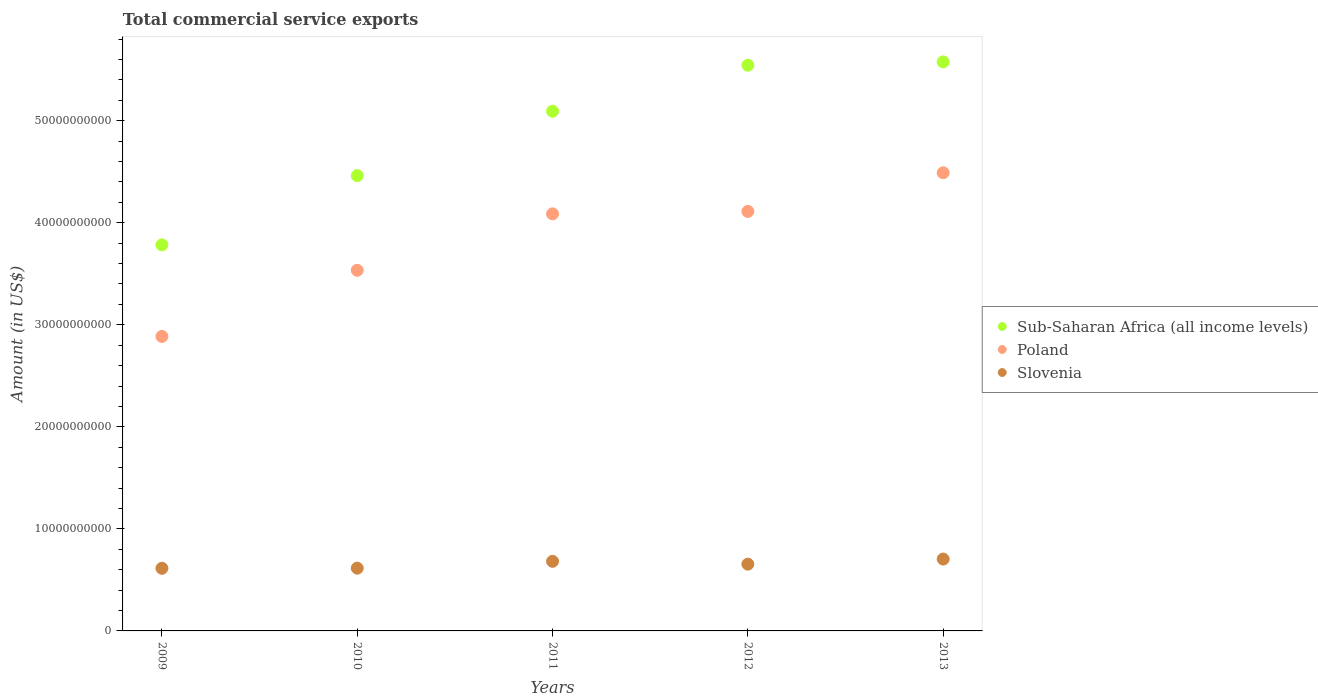Is the number of dotlines equal to the number of legend labels?
Offer a terse response. Yes. What is the total commercial service exports in Poland in 2009?
Provide a short and direct response. 2.89e+1. Across all years, what is the maximum total commercial service exports in Sub-Saharan Africa (all income levels)?
Offer a very short reply. 5.58e+1. Across all years, what is the minimum total commercial service exports in Poland?
Ensure brevity in your answer.  2.89e+1. In which year was the total commercial service exports in Poland maximum?
Provide a short and direct response. 2013. In which year was the total commercial service exports in Sub-Saharan Africa (all income levels) minimum?
Offer a terse response. 2009. What is the total total commercial service exports in Slovenia in the graph?
Keep it short and to the point. 3.27e+1. What is the difference between the total commercial service exports in Slovenia in 2010 and that in 2013?
Offer a terse response. -8.91e+08. What is the difference between the total commercial service exports in Slovenia in 2013 and the total commercial service exports in Poland in 2012?
Ensure brevity in your answer.  -3.41e+1. What is the average total commercial service exports in Sub-Saharan Africa (all income levels) per year?
Offer a very short reply. 4.89e+1. In the year 2011, what is the difference between the total commercial service exports in Poland and total commercial service exports in Slovenia?
Keep it short and to the point. 3.41e+1. What is the ratio of the total commercial service exports in Slovenia in 2009 to that in 2011?
Ensure brevity in your answer.  0.9. Is the total commercial service exports in Poland in 2009 less than that in 2012?
Make the answer very short. Yes. What is the difference between the highest and the second highest total commercial service exports in Sub-Saharan Africa (all income levels)?
Keep it short and to the point. 3.24e+08. What is the difference between the highest and the lowest total commercial service exports in Sub-Saharan Africa (all income levels)?
Your response must be concise. 1.79e+1. Is the sum of the total commercial service exports in Slovenia in 2009 and 2011 greater than the maximum total commercial service exports in Poland across all years?
Offer a terse response. No. Does the total commercial service exports in Sub-Saharan Africa (all income levels) monotonically increase over the years?
Your response must be concise. Yes. Is the total commercial service exports in Sub-Saharan Africa (all income levels) strictly greater than the total commercial service exports in Slovenia over the years?
Give a very brief answer. Yes. How many dotlines are there?
Give a very brief answer. 3. What is the difference between two consecutive major ticks on the Y-axis?
Make the answer very short. 1.00e+1. Does the graph contain any zero values?
Provide a short and direct response. No. How many legend labels are there?
Offer a very short reply. 3. How are the legend labels stacked?
Your answer should be compact. Vertical. What is the title of the graph?
Provide a short and direct response. Total commercial service exports. What is the label or title of the X-axis?
Provide a short and direct response. Years. What is the label or title of the Y-axis?
Provide a succinct answer. Amount (in US$). What is the Amount (in US$) in Sub-Saharan Africa (all income levels) in 2009?
Provide a succinct answer. 3.78e+1. What is the Amount (in US$) of Poland in 2009?
Your answer should be very brief. 2.89e+1. What is the Amount (in US$) of Slovenia in 2009?
Your response must be concise. 6.14e+09. What is the Amount (in US$) in Sub-Saharan Africa (all income levels) in 2010?
Keep it short and to the point. 4.46e+1. What is the Amount (in US$) of Poland in 2010?
Provide a succinct answer. 3.53e+1. What is the Amount (in US$) of Slovenia in 2010?
Provide a succinct answer. 6.15e+09. What is the Amount (in US$) in Sub-Saharan Africa (all income levels) in 2011?
Your response must be concise. 5.09e+1. What is the Amount (in US$) of Poland in 2011?
Keep it short and to the point. 4.09e+1. What is the Amount (in US$) of Slovenia in 2011?
Offer a very short reply. 6.82e+09. What is the Amount (in US$) in Sub-Saharan Africa (all income levels) in 2012?
Offer a very short reply. 5.54e+1. What is the Amount (in US$) in Poland in 2012?
Make the answer very short. 4.11e+1. What is the Amount (in US$) in Slovenia in 2012?
Offer a terse response. 6.54e+09. What is the Amount (in US$) of Sub-Saharan Africa (all income levels) in 2013?
Give a very brief answer. 5.58e+1. What is the Amount (in US$) of Poland in 2013?
Provide a succinct answer. 4.49e+1. What is the Amount (in US$) in Slovenia in 2013?
Provide a short and direct response. 7.04e+09. Across all years, what is the maximum Amount (in US$) of Sub-Saharan Africa (all income levels)?
Offer a very short reply. 5.58e+1. Across all years, what is the maximum Amount (in US$) in Poland?
Your answer should be very brief. 4.49e+1. Across all years, what is the maximum Amount (in US$) of Slovenia?
Offer a very short reply. 7.04e+09. Across all years, what is the minimum Amount (in US$) in Sub-Saharan Africa (all income levels)?
Your answer should be compact. 3.78e+1. Across all years, what is the minimum Amount (in US$) of Poland?
Offer a terse response. 2.89e+1. Across all years, what is the minimum Amount (in US$) in Slovenia?
Offer a terse response. 6.14e+09. What is the total Amount (in US$) in Sub-Saharan Africa (all income levels) in the graph?
Ensure brevity in your answer.  2.45e+11. What is the total Amount (in US$) in Poland in the graph?
Provide a succinct answer. 1.91e+11. What is the total Amount (in US$) in Slovenia in the graph?
Your response must be concise. 3.27e+1. What is the difference between the Amount (in US$) in Sub-Saharan Africa (all income levels) in 2009 and that in 2010?
Ensure brevity in your answer.  -6.79e+09. What is the difference between the Amount (in US$) in Poland in 2009 and that in 2010?
Provide a succinct answer. -6.48e+09. What is the difference between the Amount (in US$) in Slovenia in 2009 and that in 2010?
Offer a very short reply. -1.21e+07. What is the difference between the Amount (in US$) in Sub-Saharan Africa (all income levels) in 2009 and that in 2011?
Your response must be concise. -1.31e+1. What is the difference between the Amount (in US$) of Poland in 2009 and that in 2011?
Ensure brevity in your answer.  -1.20e+1. What is the difference between the Amount (in US$) of Slovenia in 2009 and that in 2011?
Ensure brevity in your answer.  -6.82e+08. What is the difference between the Amount (in US$) of Sub-Saharan Africa (all income levels) in 2009 and that in 2012?
Provide a short and direct response. -1.76e+1. What is the difference between the Amount (in US$) in Poland in 2009 and that in 2012?
Offer a very short reply. -1.23e+1. What is the difference between the Amount (in US$) in Slovenia in 2009 and that in 2012?
Make the answer very short. -4.06e+08. What is the difference between the Amount (in US$) in Sub-Saharan Africa (all income levels) in 2009 and that in 2013?
Keep it short and to the point. -1.79e+1. What is the difference between the Amount (in US$) of Poland in 2009 and that in 2013?
Your answer should be very brief. -1.60e+1. What is the difference between the Amount (in US$) of Slovenia in 2009 and that in 2013?
Provide a succinct answer. -9.03e+08. What is the difference between the Amount (in US$) in Sub-Saharan Africa (all income levels) in 2010 and that in 2011?
Offer a terse response. -6.31e+09. What is the difference between the Amount (in US$) of Poland in 2010 and that in 2011?
Your answer should be compact. -5.53e+09. What is the difference between the Amount (in US$) in Slovenia in 2010 and that in 2011?
Make the answer very short. -6.70e+08. What is the difference between the Amount (in US$) of Sub-Saharan Africa (all income levels) in 2010 and that in 2012?
Offer a terse response. -1.08e+1. What is the difference between the Amount (in US$) of Poland in 2010 and that in 2012?
Your answer should be very brief. -5.77e+09. What is the difference between the Amount (in US$) of Slovenia in 2010 and that in 2012?
Your response must be concise. -3.94e+08. What is the difference between the Amount (in US$) of Sub-Saharan Africa (all income levels) in 2010 and that in 2013?
Offer a terse response. -1.11e+1. What is the difference between the Amount (in US$) in Poland in 2010 and that in 2013?
Your answer should be compact. -9.56e+09. What is the difference between the Amount (in US$) in Slovenia in 2010 and that in 2013?
Provide a succinct answer. -8.91e+08. What is the difference between the Amount (in US$) of Sub-Saharan Africa (all income levels) in 2011 and that in 2012?
Your response must be concise. -4.51e+09. What is the difference between the Amount (in US$) in Poland in 2011 and that in 2012?
Make the answer very short. -2.41e+08. What is the difference between the Amount (in US$) in Slovenia in 2011 and that in 2012?
Your response must be concise. 2.76e+08. What is the difference between the Amount (in US$) in Sub-Saharan Africa (all income levels) in 2011 and that in 2013?
Offer a terse response. -4.83e+09. What is the difference between the Amount (in US$) of Poland in 2011 and that in 2013?
Your answer should be compact. -4.03e+09. What is the difference between the Amount (in US$) in Slovenia in 2011 and that in 2013?
Provide a short and direct response. -2.21e+08. What is the difference between the Amount (in US$) of Sub-Saharan Africa (all income levels) in 2012 and that in 2013?
Offer a terse response. -3.24e+08. What is the difference between the Amount (in US$) of Poland in 2012 and that in 2013?
Ensure brevity in your answer.  -3.79e+09. What is the difference between the Amount (in US$) of Slovenia in 2012 and that in 2013?
Your answer should be compact. -4.97e+08. What is the difference between the Amount (in US$) of Sub-Saharan Africa (all income levels) in 2009 and the Amount (in US$) of Poland in 2010?
Your response must be concise. 2.49e+09. What is the difference between the Amount (in US$) in Sub-Saharan Africa (all income levels) in 2009 and the Amount (in US$) in Slovenia in 2010?
Your answer should be compact. 3.17e+1. What is the difference between the Amount (in US$) in Poland in 2009 and the Amount (in US$) in Slovenia in 2010?
Offer a terse response. 2.27e+1. What is the difference between the Amount (in US$) of Sub-Saharan Africa (all income levels) in 2009 and the Amount (in US$) of Poland in 2011?
Your answer should be very brief. -3.04e+09. What is the difference between the Amount (in US$) in Sub-Saharan Africa (all income levels) in 2009 and the Amount (in US$) in Slovenia in 2011?
Offer a terse response. 3.10e+1. What is the difference between the Amount (in US$) in Poland in 2009 and the Amount (in US$) in Slovenia in 2011?
Ensure brevity in your answer.  2.20e+1. What is the difference between the Amount (in US$) of Sub-Saharan Africa (all income levels) in 2009 and the Amount (in US$) of Poland in 2012?
Your answer should be compact. -3.28e+09. What is the difference between the Amount (in US$) in Sub-Saharan Africa (all income levels) in 2009 and the Amount (in US$) in Slovenia in 2012?
Offer a terse response. 3.13e+1. What is the difference between the Amount (in US$) in Poland in 2009 and the Amount (in US$) in Slovenia in 2012?
Give a very brief answer. 2.23e+1. What is the difference between the Amount (in US$) in Sub-Saharan Africa (all income levels) in 2009 and the Amount (in US$) in Poland in 2013?
Ensure brevity in your answer.  -7.07e+09. What is the difference between the Amount (in US$) of Sub-Saharan Africa (all income levels) in 2009 and the Amount (in US$) of Slovenia in 2013?
Provide a succinct answer. 3.08e+1. What is the difference between the Amount (in US$) in Poland in 2009 and the Amount (in US$) in Slovenia in 2013?
Offer a very short reply. 2.18e+1. What is the difference between the Amount (in US$) of Sub-Saharan Africa (all income levels) in 2010 and the Amount (in US$) of Poland in 2011?
Make the answer very short. 3.75e+09. What is the difference between the Amount (in US$) in Sub-Saharan Africa (all income levels) in 2010 and the Amount (in US$) in Slovenia in 2011?
Your answer should be compact. 3.78e+1. What is the difference between the Amount (in US$) in Poland in 2010 and the Amount (in US$) in Slovenia in 2011?
Ensure brevity in your answer.  2.85e+1. What is the difference between the Amount (in US$) of Sub-Saharan Africa (all income levels) in 2010 and the Amount (in US$) of Poland in 2012?
Offer a very short reply. 3.51e+09. What is the difference between the Amount (in US$) of Sub-Saharan Africa (all income levels) in 2010 and the Amount (in US$) of Slovenia in 2012?
Make the answer very short. 3.81e+1. What is the difference between the Amount (in US$) in Poland in 2010 and the Amount (in US$) in Slovenia in 2012?
Provide a short and direct response. 2.88e+1. What is the difference between the Amount (in US$) of Sub-Saharan Africa (all income levels) in 2010 and the Amount (in US$) of Poland in 2013?
Your answer should be very brief. -2.80e+08. What is the difference between the Amount (in US$) in Sub-Saharan Africa (all income levels) in 2010 and the Amount (in US$) in Slovenia in 2013?
Ensure brevity in your answer.  3.76e+1. What is the difference between the Amount (in US$) in Poland in 2010 and the Amount (in US$) in Slovenia in 2013?
Your response must be concise. 2.83e+1. What is the difference between the Amount (in US$) in Sub-Saharan Africa (all income levels) in 2011 and the Amount (in US$) in Poland in 2012?
Offer a very short reply. 9.82e+09. What is the difference between the Amount (in US$) in Sub-Saharan Africa (all income levels) in 2011 and the Amount (in US$) in Slovenia in 2012?
Offer a very short reply. 4.44e+1. What is the difference between the Amount (in US$) of Poland in 2011 and the Amount (in US$) of Slovenia in 2012?
Offer a terse response. 3.43e+1. What is the difference between the Amount (in US$) in Sub-Saharan Africa (all income levels) in 2011 and the Amount (in US$) in Poland in 2013?
Make the answer very short. 6.03e+09. What is the difference between the Amount (in US$) in Sub-Saharan Africa (all income levels) in 2011 and the Amount (in US$) in Slovenia in 2013?
Your answer should be very brief. 4.39e+1. What is the difference between the Amount (in US$) of Poland in 2011 and the Amount (in US$) of Slovenia in 2013?
Offer a very short reply. 3.38e+1. What is the difference between the Amount (in US$) of Sub-Saharan Africa (all income levels) in 2012 and the Amount (in US$) of Poland in 2013?
Make the answer very short. 1.05e+1. What is the difference between the Amount (in US$) of Sub-Saharan Africa (all income levels) in 2012 and the Amount (in US$) of Slovenia in 2013?
Offer a very short reply. 4.84e+1. What is the difference between the Amount (in US$) of Poland in 2012 and the Amount (in US$) of Slovenia in 2013?
Provide a succinct answer. 3.41e+1. What is the average Amount (in US$) of Sub-Saharan Africa (all income levels) per year?
Your answer should be compact. 4.89e+1. What is the average Amount (in US$) of Poland per year?
Your response must be concise. 3.82e+1. What is the average Amount (in US$) of Slovenia per year?
Make the answer very short. 6.54e+09. In the year 2009, what is the difference between the Amount (in US$) of Sub-Saharan Africa (all income levels) and Amount (in US$) of Poland?
Provide a short and direct response. 8.97e+09. In the year 2009, what is the difference between the Amount (in US$) in Sub-Saharan Africa (all income levels) and Amount (in US$) in Slovenia?
Provide a succinct answer. 3.17e+1. In the year 2009, what is the difference between the Amount (in US$) in Poland and Amount (in US$) in Slovenia?
Give a very brief answer. 2.27e+1. In the year 2010, what is the difference between the Amount (in US$) in Sub-Saharan Africa (all income levels) and Amount (in US$) in Poland?
Make the answer very short. 9.28e+09. In the year 2010, what is the difference between the Amount (in US$) of Sub-Saharan Africa (all income levels) and Amount (in US$) of Slovenia?
Your answer should be very brief. 3.85e+1. In the year 2010, what is the difference between the Amount (in US$) in Poland and Amount (in US$) in Slovenia?
Provide a succinct answer. 2.92e+1. In the year 2011, what is the difference between the Amount (in US$) in Sub-Saharan Africa (all income levels) and Amount (in US$) in Poland?
Provide a short and direct response. 1.01e+1. In the year 2011, what is the difference between the Amount (in US$) of Sub-Saharan Africa (all income levels) and Amount (in US$) of Slovenia?
Offer a very short reply. 4.41e+1. In the year 2011, what is the difference between the Amount (in US$) in Poland and Amount (in US$) in Slovenia?
Your answer should be compact. 3.41e+1. In the year 2012, what is the difference between the Amount (in US$) in Sub-Saharan Africa (all income levels) and Amount (in US$) in Poland?
Give a very brief answer. 1.43e+1. In the year 2012, what is the difference between the Amount (in US$) in Sub-Saharan Africa (all income levels) and Amount (in US$) in Slovenia?
Offer a terse response. 4.89e+1. In the year 2012, what is the difference between the Amount (in US$) in Poland and Amount (in US$) in Slovenia?
Give a very brief answer. 3.46e+1. In the year 2013, what is the difference between the Amount (in US$) of Sub-Saharan Africa (all income levels) and Amount (in US$) of Poland?
Give a very brief answer. 1.09e+1. In the year 2013, what is the difference between the Amount (in US$) of Sub-Saharan Africa (all income levels) and Amount (in US$) of Slovenia?
Your answer should be very brief. 4.87e+1. In the year 2013, what is the difference between the Amount (in US$) of Poland and Amount (in US$) of Slovenia?
Ensure brevity in your answer.  3.79e+1. What is the ratio of the Amount (in US$) of Sub-Saharan Africa (all income levels) in 2009 to that in 2010?
Give a very brief answer. 0.85. What is the ratio of the Amount (in US$) of Poland in 2009 to that in 2010?
Offer a very short reply. 0.82. What is the ratio of the Amount (in US$) of Sub-Saharan Africa (all income levels) in 2009 to that in 2011?
Ensure brevity in your answer.  0.74. What is the ratio of the Amount (in US$) of Poland in 2009 to that in 2011?
Give a very brief answer. 0.71. What is the ratio of the Amount (in US$) in Slovenia in 2009 to that in 2011?
Your answer should be very brief. 0.9. What is the ratio of the Amount (in US$) in Sub-Saharan Africa (all income levels) in 2009 to that in 2012?
Offer a terse response. 0.68. What is the ratio of the Amount (in US$) of Poland in 2009 to that in 2012?
Your answer should be compact. 0.7. What is the ratio of the Amount (in US$) of Slovenia in 2009 to that in 2012?
Keep it short and to the point. 0.94. What is the ratio of the Amount (in US$) in Sub-Saharan Africa (all income levels) in 2009 to that in 2013?
Ensure brevity in your answer.  0.68. What is the ratio of the Amount (in US$) in Poland in 2009 to that in 2013?
Keep it short and to the point. 0.64. What is the ratio of the Amount (in US$) in Slovenia in 2009 to that in 2013?
Give a very brief answer. 0.87. What is the ratio of the Amount (in US$) in Sub-Saharan Africa (all income levels) in 2010 to that in 2011?
Make the answer very short. 0.88. What is the ratio of the Amount (in US$) of Poland in 2010 to that in 2011?
Provide a short and direct response. 0.86. What is the ratio of the Amount (in US$) in Slovenia in 2010 to that in 2011?
Give a very brief answer. 0.9. What is the ratio of the Amount (in US$) of Sub-Saharan Africa (all income levels) in 2010 to that in 2012?
Offer a terse response. 0.8. What is the ratio of the Amount (in US$) of Poland in 2010 to that in 2012?
Your answer should be very brief. 0.86. What is the ratio of the Amount (in US$) of Slovenia in 2010 to that in 2012?
Ensure brevity in your answer.  0.94. What is the ratio of the Amount (in US$) of Sub-Saharan Africa (all income levels) in 2010 to that in 2013?
Your response must be concise. 0.8. What is the ratio of the Amount (in US$) of Poland in 2010 to that in 2013?
Ensure brevity in your answer.  0.79. What is the ratio of the Amount (in US$) in Slovenia in 2010 to that in 2013?
Your answer should be compact. 0.87. What is the ratio of the Amount (in US$) in Sub-Saharan Africa (all income levels) in 2011 to that in 2012?
Make the answer very short. 0.92. What is the ratio of the Amount (in US$) in Poland in 2011 to that in 2012?
Your answer should be very brief. 0.99. What is the ratio of the Amount (in US$) in Slovenia in 2011 to that in 2012?
Offer a very short reply. 1.04. What is the ratio of the Amount (in US$) in Sub-Saharan Africa (all income levels) in 2011 to that in 2013?
Provide a short and direct response. 0.91. What is the ratio of the Amount (in US$) of Poland in 2011 to that in 2013?
Make the answer very short. 0.91. What is the ratio of the Amount (in US$) in Slovenia in 2011 to that in 2013?
Your answer should be very brief. 0.97. What is the ratio of the Amount (in US$) of Sub-Saharan Africa (all income levels) in 2012 to that in 2013?
Make the answer very short. 0.99. What is the ratio of the Amount (in US$) of Poland in 2012 to that in 2013?
Your answer should be compact. 0.92. What is the ratio of the Amount (in US$) of Slovenia in 2012 to that in 2013?
Your answer should be very brief. 0.93. What is the difference between the highest and the second highest Amount (in US$) in Sub-Saharan Africa (all income levels)?
Give a very brief answer. 3.24e+08. What is the difference between the highest and the second highest Amount (in US$) in Poland?
Offer a terse response. 3.79e+09. What is the difference between the highest and the second highest Amount (in US$) in Slovenia?
Ensure brevity in your answer.  2.21e+08. What is the difference between the highest and the lowest Amount (in US$) in Sub-Saharan Africa (all income levels)?
Ensure brevity in your answer.  1.79e+1. What is the difference between the highest and the lowest Amount (in US$) of Poland?
Offer a terse response. 1.60e+1. What is the difference between the highest and the lowest Amount (in US$) of Slovenia?
Give a very brief answer. 9.03e+08. 